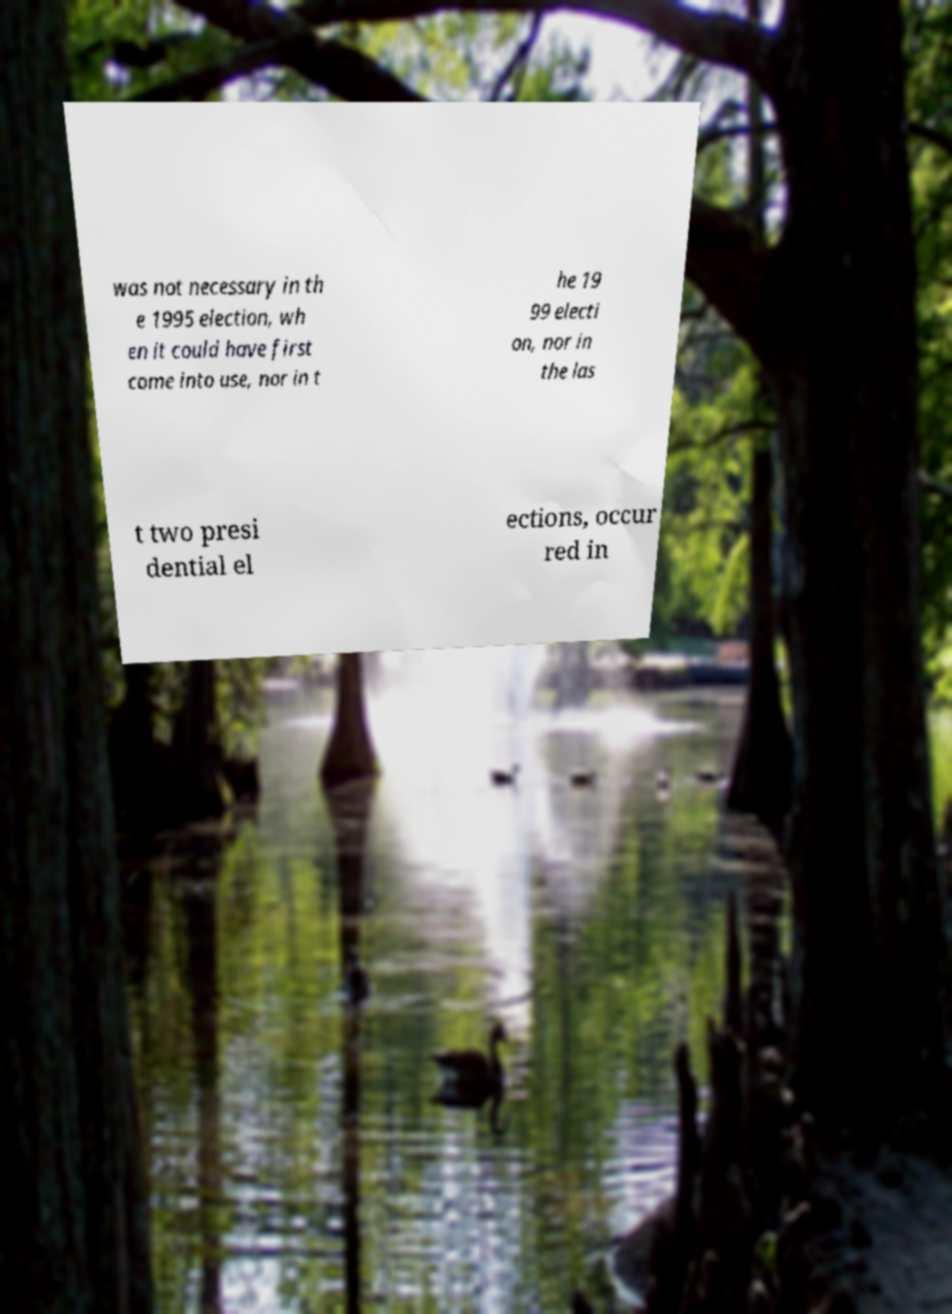There's text embedded in this image that I need extracted. Can you transcribe it verbatim? was not necessary in th e 1995 election, wh en it could have first come into use, nor in t he 19 99 electi on, nor in the las t two presi dential el ections, occur red in 